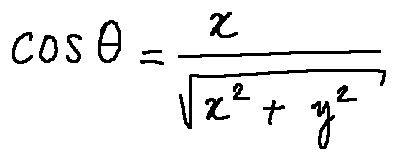<formula> <loc_0><loc_0><loc_500><loc_500>\cos \theta = \frac { x } { \sqrt { x ^ { 2 } + y ^ { 2 } } }</formula> 